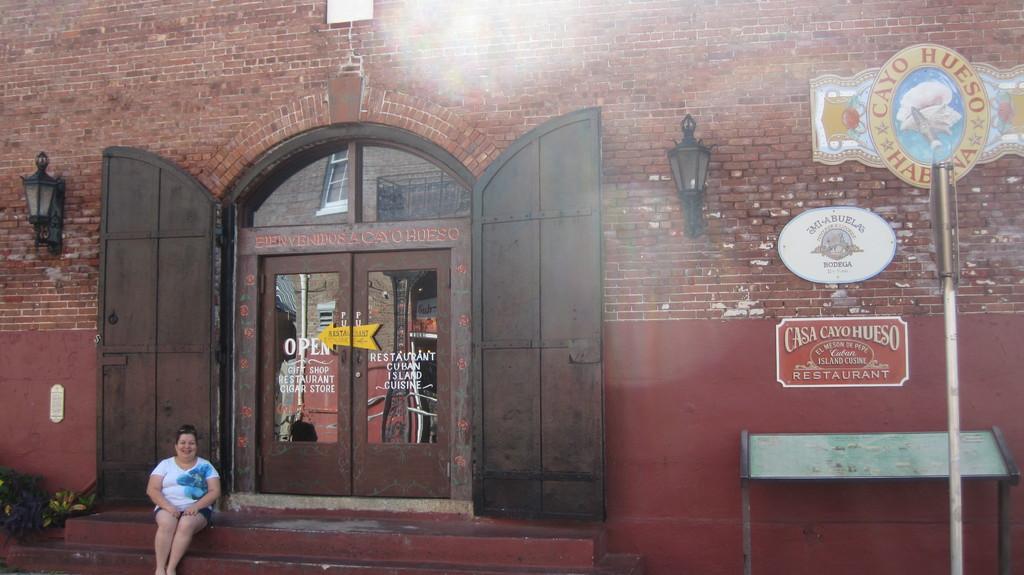Describe this image in one or two sentences. In this image I can see a person sitting and the person is wearing white and blue color shirt. Background I can see two glass doors and I can also see few boards attached to the wall and the wall is in brown color and I can also see two light poles. 